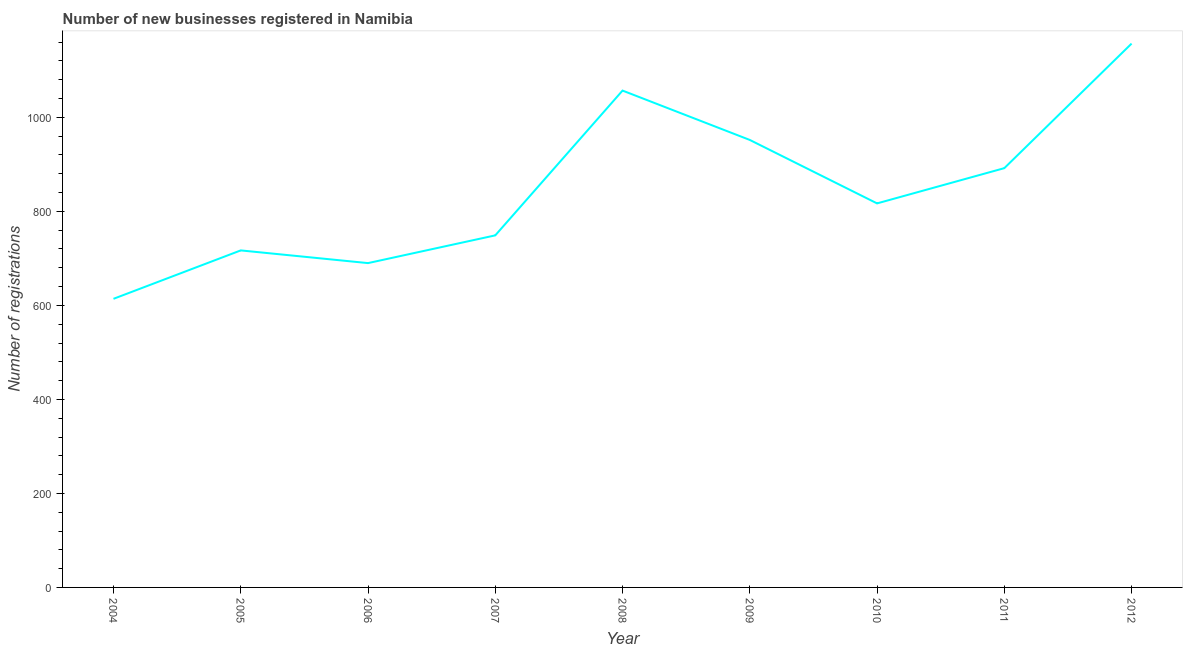What is the number of new business registrations in 2006?
Ensure brevity in your answer.  690. Across all years, what is the maximum number of new business registrations?
Your answer should be very brief. 1157. Across all years, what is the minimum number of new business registrations?
Give a very brief answer. 614. In which year was the number of new business registrations maximum?
Your answer should be compact. 2012. In which year was the number of new business registrations minimum?
Your response must be concise. 2004. What is the sum of the number of new business registrations?
Provide a succinct answer. 7645. What is the difference between the number of new business registrations in 2007 and 2012?
Offer a terse response. -408. What is the average number of new business registrations per year?
Your answer should be very brief. 849.44. What is the median number of new business registrations?
Offer a very short reply. 817. What is the ratio of the number of new business registrations in 2006 to that in 2009?
Offer a terse response. 0.72. Is the number of new business registrations in 2005 less than that in 2011?
Ensure brevity in your answer.  Yes. Is the difference between the number of new business registrations in 2005 and 2011 greater than the difference between any two years?
Offer a very short reply. No. What is the difference between the highest and the second highest number of new business registrations?
Provide a succinct answer. 100. What is the difference between the highest and the lowest number of new business registrations?
Make the answer very short. 543. Does the number of new business registrations monotonically increase over the years?
Provide a short and direct response. No. Does the graph contain any zero values?
Give a very brief answer. No. Does the graph contain grids?
Ensure brevity in your answer.  No. What is the title of the graph?
Make the answer very short. Number of new businesses registered in Namibia. What is the label or title of the X-axis?
Ensure brevity in your answer.  Year. What is the label or title of the Y-axis?
Ensure brevity in your answer.  Number of registrations. What is the Number of registrations in 2004?
Your answer should be compact. 614. What is the Number of registrations of 2005?
Provide a succinct answer. 717. What is the Number of registrations in 2006?
Ensure brevity in your answer.  690. What is the Number of registrations of 2007?
Offer a very short reply. 749. What is the Number of registrations in 2008?
Provide a short and direct response. 1057. What is the Number of registrations of 2009?
Offer a terse response. 952. What is the Number of registrations of 2010?
Make the answer very short. 817. What is the Number of registrations in 2011?
Your answer should be very brief. 892. What is the Number of registrations of 2012?
Your answer should be very brief. 1157. What is the difference between the Number of registrations in 2004 and 2005?
Offer a very short reply. -103. What is the difference between the Number of registrations in 2004 and 2006?
Ensure brevity in your answer.  -76. What is the difference between the Number of registrations in 2004 and 2007?
Your response must be concise. -135. What is the difference between the Number of registrations in 2004 and 2008?
Offer a terse response. -443. What is the difference between the Number of registrations in 2004 and 2009?
Make the answer very short. -338. What is the difference between the Number of registrations in 2004 and 2010?
Give a very brief answer. -203. What is the difference between the Number of registrations in 2004 and 2011?
Ensure brevity in your answer.  -278. What is the difference between the Number of registrations in 2004 and 2012?
Your answer should be compact. -543. What is the difference between the Number of registrations in 2005 and 2007?
Ensure brevity in your answer.  -32. What is the difference between the Number of registrations in 2005 and 2008?
Ensure brevity in your answer.  -340. What is the difference between the Number of registrations in 2005 and 2009?
Give a very brief answer. -235. What is the difference between the Number of registrations in 2005 and 2010?
Ensure brevity in your answer.  -100. What is the difference between the Number of registrations in 2005 and 2011?
Make the answer very short. -175. What is the difference between the Number of registrations in 2005 and 2012?
Keep it short and to the point. -440. What is the difference between the Number of registrations in 2006 and 2007?
Your answer should be compact. -59. What is the difference between the Number of registrations in 2006 and 2008?
Offer a terse response. -367. What is the difference between the Number of registrations in 2006 and 2009?
Give a very brief answer. -262. What is the difference between the Number of registrations in 2006 and 2010?
Offer a very short reply. -127. What is the difference between the Number of registrations in 2006 and 2011?
Your response must be concise. -202. What is the difference between the Number of registrations in 2006 and 2012?
Your answer should be compact. -467. What is the difference between the Number of registrations in 2007 and 2008?
Ensure brevity in your answer.  -308. What is the difference between the Number of registrations in 2007 and 2009?
Ensure brevity in your answer.  -203. What is the difference between the Number of registrations in 2007 and 2010?
Make the answer very short. -68. What is the difference between the Number of registrations in 2007 and 2011?
Offer a very short reply. -143. What is the difference between the Number of registrations in 2007 and 2012?
Ensure brevity in your answer.  -408. What is the difference between the Number of registrations in 2008 and 2009?
Offer a terse response. 105. What is the difference between the Number of registrations in 2008 and 2010?
Your answer should be very brief. 240. What is the difference between the Number of registrations in 2008 and 2011?
Provide a short and direct response. 165. What is the difference between the Number of registrations in 2008 and 2012?
Your answer should be compact. -100. What is the difference between the Number of registrations in 2009 and 2010?
Give a very brief answer. 135. What is the difference between the Number of registrations in 2009 and 2011?
Offer a very short reply. 60. What is the difference between the Number of registrations in 2009 and 2012?
Ensure brevity in your answer.  -205. What is the difference between the Number of registrations in 2010 and 2011?
Make the answer very short. -75. What is the difference between the Number of registrations in 2010 and 2012?
Give a very brief answer. -340. What is the difference between the Number of registrations in 2011 and 2012?
Your answer should be compact. -265. What is the ratio of the Number of registrations in 2004 to that in 2005?
Your response must be concise. 0.86. What is the ratio of the Number of registrations in 2004 to that in 2006?
Provide a short and direct response. 0.89. What is the ratio of the Number of registrations in 2004 to that in 2007?
Give a very brief answer. 0.82. What is the ratio of the Number of registrations in 2004 to that in 2008?
Keep it short and to the point. 0.58. What is the ratio of the Number of registrations in 2004 to that in 2009?
Make the answer very short. 0.65. What is the ratio of the Number of registrations in 2004 to that in 2010?
Make the answer very short. 0.75. What is the ratio of the Number of registrations in 2004 to that in 2011?
Keep it short and to the point. 0.69. What is the ratio of the Number of registrations in 2004 to that in 2012?
Your response must be concise. 0.53. What is the ratio of the Number of registrations in 2005 to that in 2006?
Make the answer very short. 1.04. What is the ratio of the Number of registrations in 2005 to that in 2008?
Ensure brevity in your answer.  0.68. What is the ratio of the Number of registrations in 2005 to that in 2009?
Keep it short and to the point. 0.75. What is the ratio of the Number of registrations in 2005 to that in 2010?
Offer a terse response. 0.88. What is the ratio of the Number of registrations in 2005 to that in 2011?
Your response must be concise. 0.8. What is the ratio of the Number of registrations in 2005 to that in 2012?
Your answer should be compact. 0.62. What is the ratio of the Number of registrations in 2006 to that in 2007?
Provide a short and direct response. 0.92. What is the ratio of the Number of registrations in 2006 to that in 2008?
Your answer should be very brief. 0.65. What is the ratio of the Number of registrations in 2006 to that in 2009?
Provide a short and direct response. 0.72. What is the ratio of the Number of registrations in 2006 to that in 2010?
Your answer should be compact. 0.84. What is the ratio of the Number of registrations in 2006 to that in 2011?
Provide a succinct answer. 0.77. What is the ratio of the Number of registrations in 2006 to that in 2012?
Make the answer very short. 0.6. What is the ratio of the Number of registrations in 2007 to that in 2008?
Your answer should be compact. 0.71. What is the ratio of the Number of registrations in 2007 to that in 2009?
Offer a terse response. 0.79. What is the ratio of the Number of registrations in 2007 to that in 2010?
Keep it short and to the point. 0.92. What is the ratio of the Number of registrations in 2007 to that in 2011?
Provide a succinct answer. 0.84. What is the ratio of the Number of registrations in 2007 to that in 2012?
Give a very brief answer. 0.65. What is the ratio of the Number of registrations in 2008 to that in 2009?
Your answer should be very brief. 1.11. What is the ratio of the Number of registrations in 2008 to that in 2010?
Your answer should be very brief. 1.29. What is the ratio of the Number of registrations in 2008 to that in 2011?
Provide a succinct answer. 1.19. What is the ratio of the Number of registrations in 2008 to that in 2012?
Keep it short and to the point. 0.91. What is the ratio of the Number of registrations in 2009 to that in 2010?
Make the answer very short. 1.17. What is the ratio of the Number of registrations in 2009 to that in 2011?
Provide a succinct answer. 1.07. What is the ratio of the Number of registrations in 2009 to that in 2012?
Ensure brevity in your answer.  0.82. What is the ratio of the Number of registrations in 2010 to that in 2011?
Your response must be concise. 0.92. What is the ratio of the Number of registrations in 2010 to that in 2012?
Provide a short and direct response. 0.71. What is the ratio of the Number of registrations in 2011 to that in 2012?
Your answer should be very brief. 0.77. 